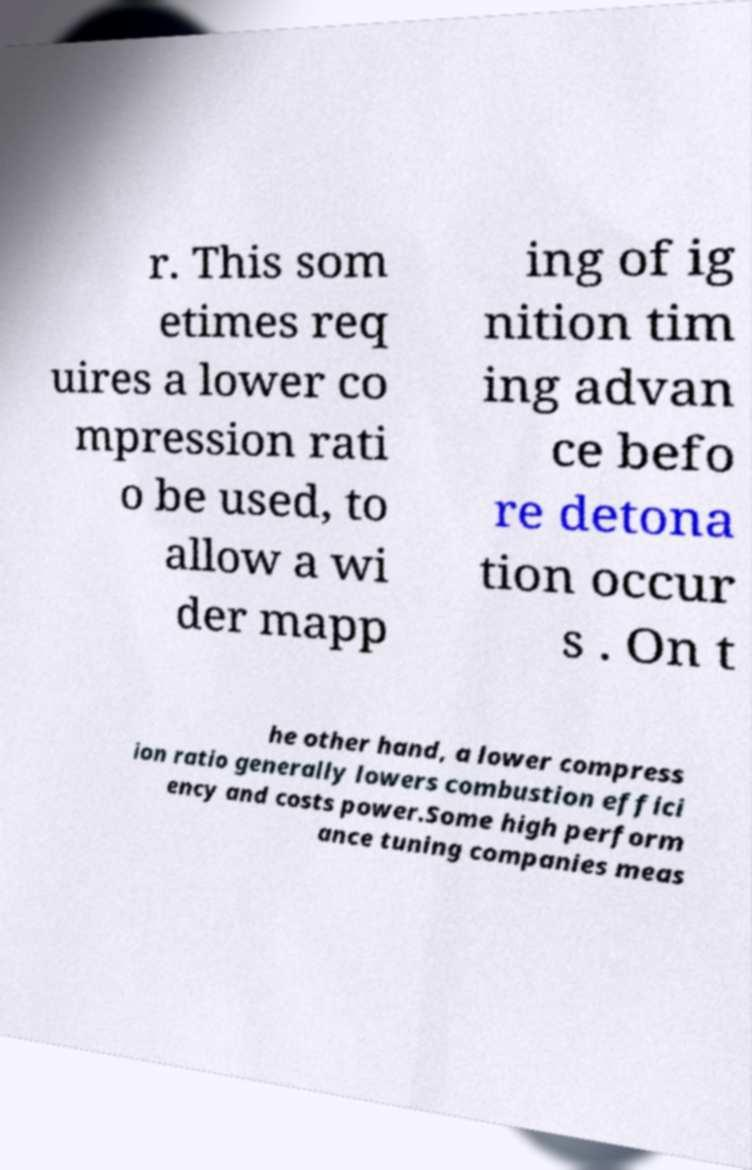I need the written content from this picture converted into text. Can you do that? r. This som etimes req uires a lower co mpression rati o be used, to allow a wi der mapp ing of ig nition tim ing advan ce befo re detona tion occur s . On t he other hand, a lower compress ion ratio generally lowers combustion effici ency and costs power.Some high perform ance tuning companies meas 